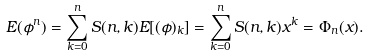<formula> <loc_0><loc_0><loc_500><loc_500>E ( \phi ^ { n } ) = \sum _ { k = 0 } ^ { n } S ( n , k ) E [ ( \phi ) _ { k } ] = \sum _ { k = 0 } ^ { n } S ( n , k ) x ^ { k } = \Phi _ { n } ( x ) .</formula> 